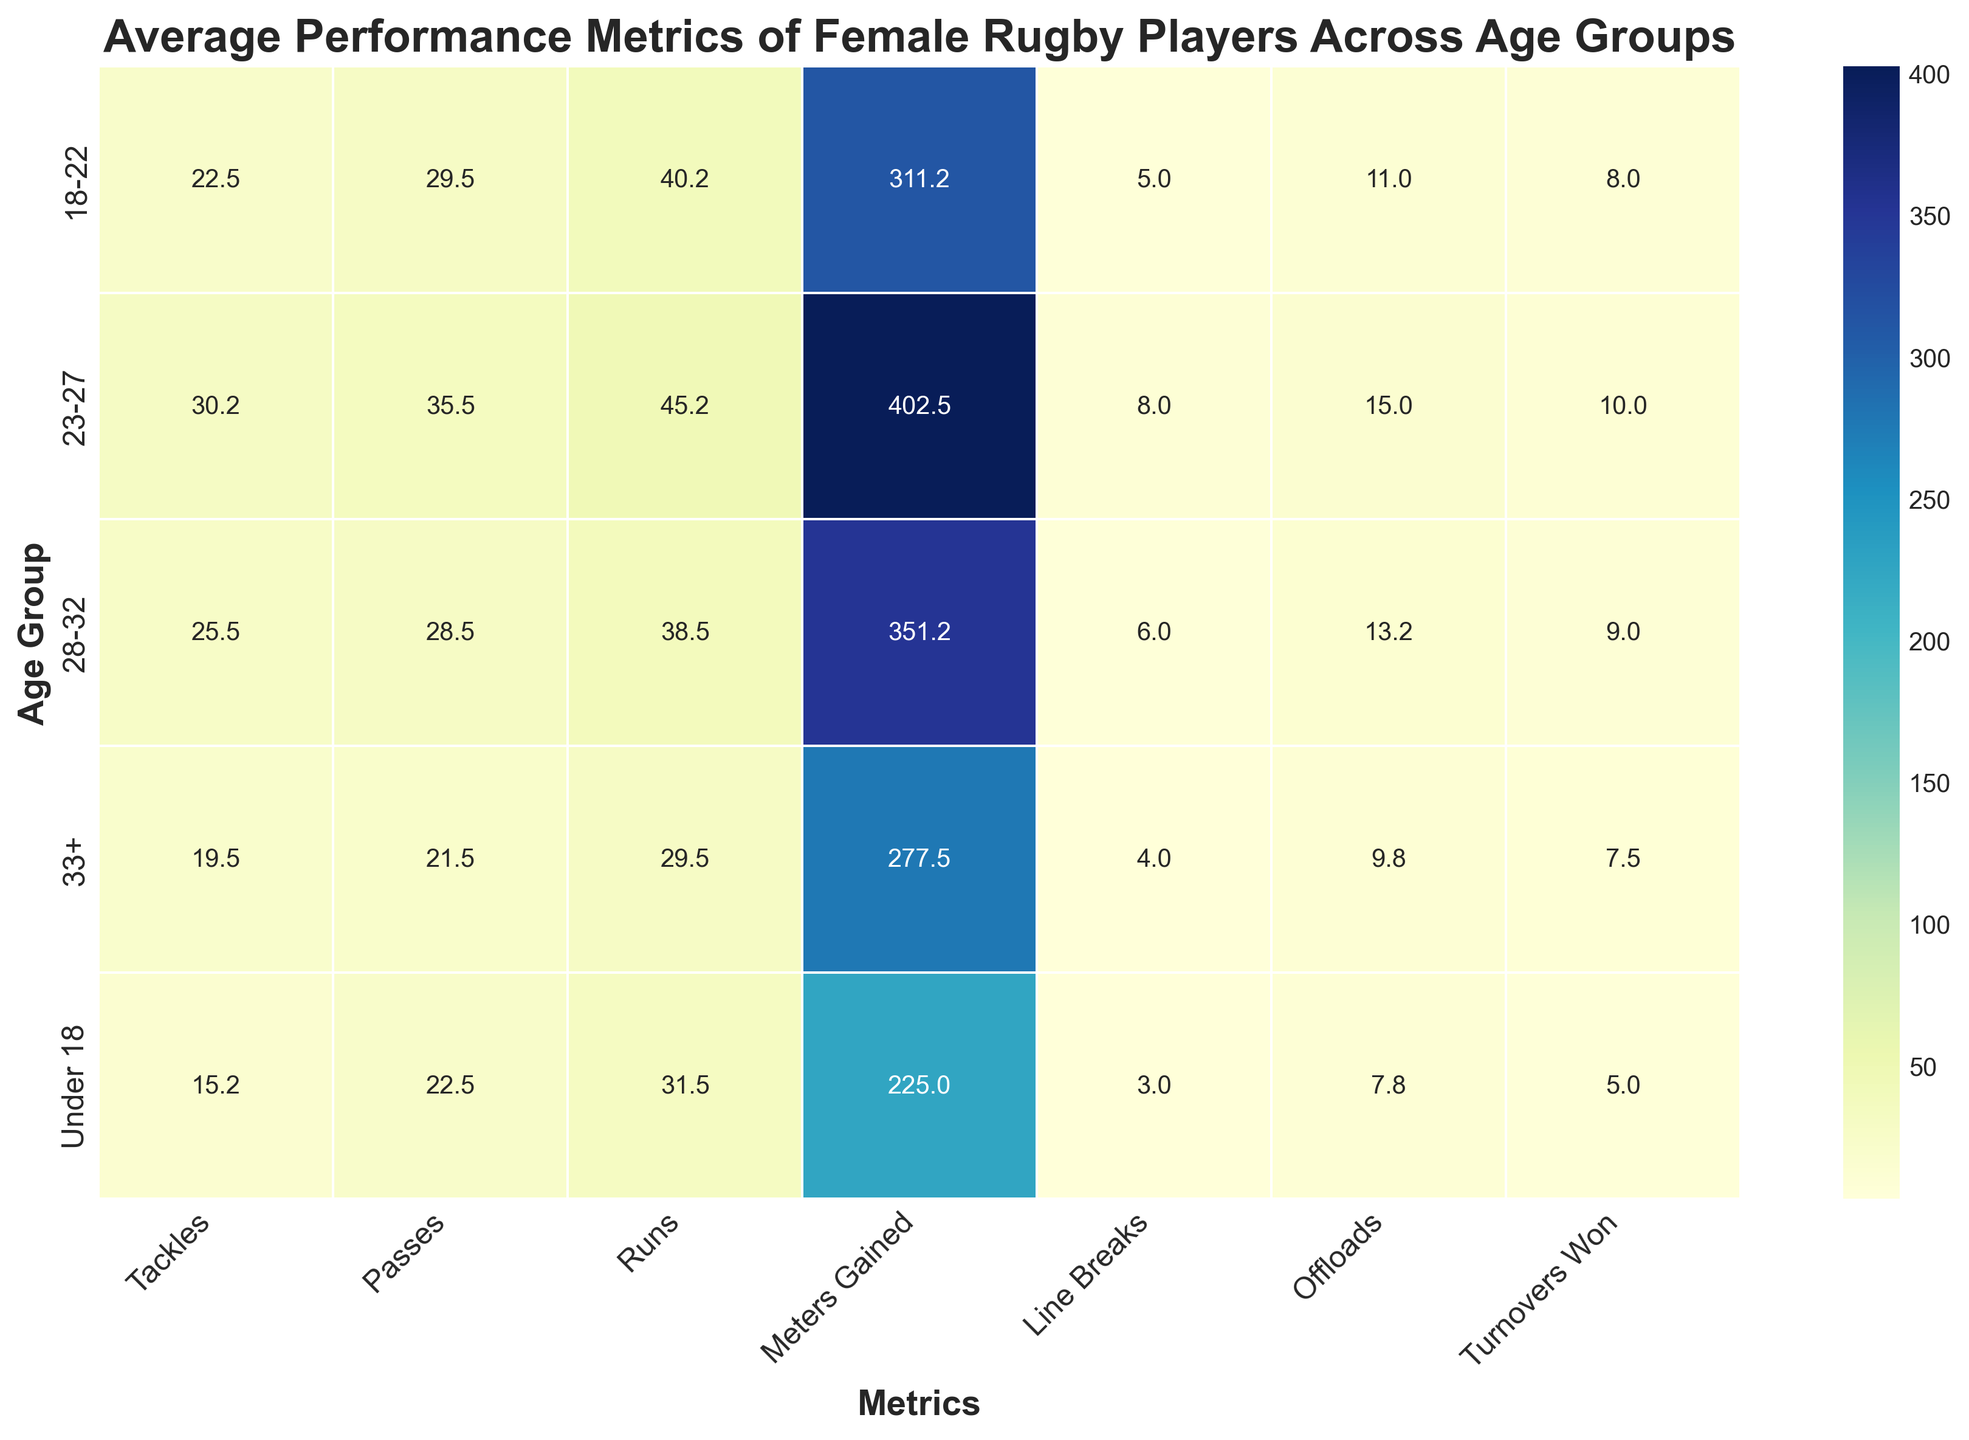What age group has the highest average number of runs? By examining the heatmap, we look for the darkest shade in the Runs column. The 23-27 age group has the highest average number of runs, being more intense in shade.
Answer: 23-27 Which age group has the lowest average number of tackle counts? We observe the Tackle column in the heatmap to identify the lightest shade. The Under 18 group shows the lightest color, indicating the lowest average tackle count.
Answer: Under 18 Compare the average meters gained between the 18-22 and 28-32 age groups. Which one is higher and by how much? The heatmap shows average meters gained for 18-22 is 311.3 and for 28-32 is 351.3. To find out by how much, subtract 311.3 from 351.3, which gives 40.
Answer: 28-32 by 40 What is the average number of turnovers won for the 33+ age group? Look at the 33+ row in the Turnovers Won column and identify the shade. The annotated value shows the average number of turnovers won is 7.5.
Answer: 7.5 What is the difference between the average number of offloads for the age groups Under 18 and 23-27? The heatmap shows Under 18 age group with an average of 7.8 offloads and 23-27 with 15.0 offloads. To find the difference, subtract 7.8 from 15.0 which equals 7.2.
Answer: 7.2 Which age group has the highest average number of line breaks and by how much compared to the lowest one? The highest average line breaks is in the 23-27 group with 8.0, and the lowest is in the Under 18 group with 3.0. The difference is calculated as 8.0 - 3.0 = 5.
Answer: 23-27 by 5 Which two metrics show the greatest average differences between the 18-22 and 33+ age groups? Compare all metrics between these groups: Tackles (21.5 vs 19.5), Passes (29.5 vs 21.5), Runs (40.3 vs 29.5), Meters Gained (311.3 vs 277.5), Line Breaks (5.0 vs 4.0), Offloads (10.5 vs 9.8), Turnovers Won (8.0 vs 7.5). The greatest differences are in Passes (29.5 - 21.5 = 8) and Meters Gained (311.3 - 277.5 = 33.8).
Answer: Passes, Meters Gained 